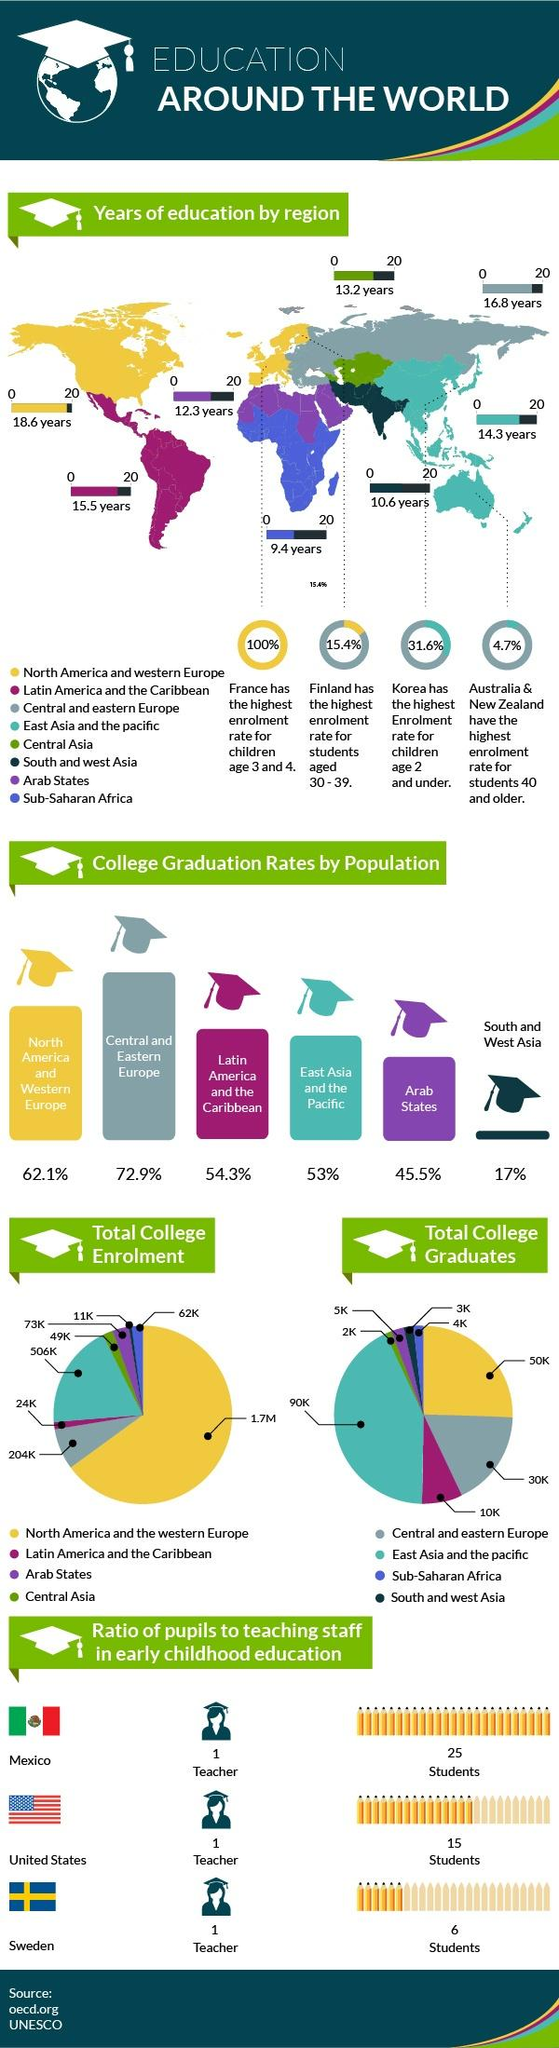Mention a couple of crucial points in this snapshot. There are approximately 10,000 college graduates in Latin America and the Caribbean. There are approximately 4,000 college graduates in Sub-Saharan Africa. According to recent statistics, the total college enrollment in North America and western Europe amounts to approximately 1.7 million students. The total number of college graduates in North America and western Europe is approximately 50,000. It is reported that the teacher to student ratio in Mexico is the lowest among the countries considered, which are Mexico, Sweden, and the United States. Based on this information, it can be concluded that Mexico has the lowest teacher to student ratio. 